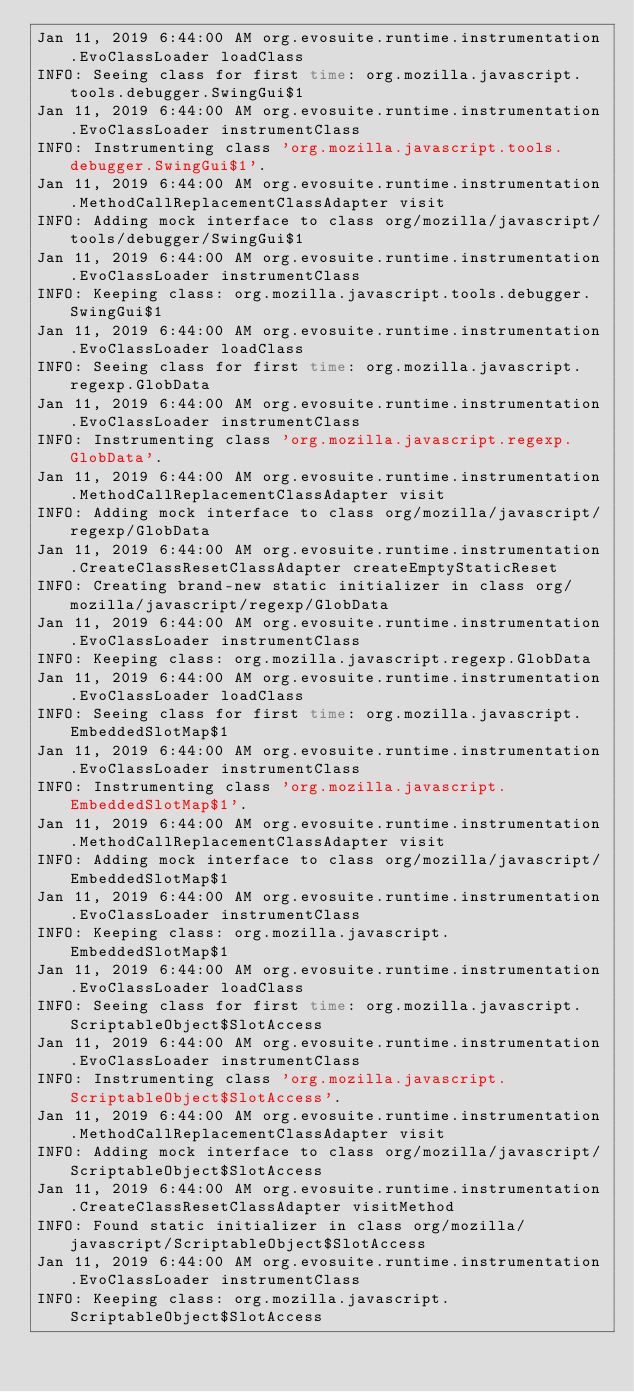<code> <loc_0><loc_0><loc_500><loc_500><_HTML_>Jan 11, 2019 6:44:00 AM org.evosuite.runtime.instrumentation.EvoClassLoader loadClass
INFO: Seeing class for first time: org.mozilla.javascript.tools.debugger.SwingGui$1
Jan 11, 2019 6:44:00 AM org.evosuite.runtime.instrumentation.EvoClassLoader instrumentClass
INFO: Instrumenting class 'org.mozilla.javascript.tools.debugger.SwingGui$1'.
Jan 11, 2019 6:44:00 AM org.evosuite.runtime.instrumentation.MethodCallReplacementClassAdapter visit
INFO: Adding mock interface to class org/mozilla/javascript/tools/debugger/SwingGui$1
Jan 11, 2019 6:44:00 AM org.evosuite.runtime.instrumentation.EvoClassLoader instrumentClass
INFO: Keeping class: org.mozilla.javascript.tools.debugger.SwingGui$1
Jan 11, 2019 6:44:00 AM org.evosuite.runtime.instrumentation.EvoClassLoader loadClass
INFO: Seeing class for first time: org.mozilla.javascript.regexp.GlobData
Jan 11, 2019 6:44:00 AM org.evosuite.runtime.instrumentation.EvoClassLoader instrumentClass
INFO: Instrumenting class 'org.mozilla.javascript.regexp.GlobData'.
Jan 11, 2019 6:44:00 AM org.evosuite.runtime.instrumentation.MethodCallReplacementClassAdapter visit
INFO: Adding mock interface to class org/mozilla/javascript/regexp/GlobData
Jan 11, 2019 6:44:00 AM org.evosuite.runtime.instrumentation.CreateClassResetClassAdapter createEmptyStaticReset
INFO: Creating brand-new static initializer in class org/mozilla/javascript/regexp/GlobData
Jan 11, 2019 6:44:00 AM org.evosuite.runtime.instrumentation.EvoClassLoader instrumentClass
INFO: Keeping class: org.mozilla.javascript.regexp.GlobData
Jan 11, 2019 6:44:00 AM org.evosuite.runtime.instrumentation.EvoClassLoader loadClass
INFO: Seeing class for first time: org.mozilla.javascript.EmbeddedSlotMap$1
Jan 11, 2019 6:44:00 AM org.evosuite.runtime.instrumentation.EvoClassLoader instrumentClass
INFO: Instrumenting class 'org.mozilla.javascript.EmbeddedSlotMap$1'.
Jan 11, 2019 6:44:00 AM org.evosuite.runtime.instrumentation.MethodCallReplacementClassAdapter visit
INFO: Adding mock interface to class org/mozilla/javascript/EmbeddedSlotMap$1
Jan 11, 2019 6:44:00 AM org.evosuite.runtime.instrumentation.EvoClassLoader instrumentClass
INFO: Keeping class: org.mozilla.javascript.EmbeddedSlotMap$1
Jan 11, 2019 6:44:00 AM org.evosuite.runtime.instrumentation.EvoClassLoader loadClass
INFO: Seeing class for first time: org.mozilla.javascript.ScriptableObject$SlotAccess
Jan 11, 2019 6:44:00 AM org.evosuite.runtime.instrumentation.EvoClassLoader instrumentClass
INFO: Instrumenting class 'org.mozilla.javascript.ScriptableObject$SlotAccess'.
Jan 11, 2019 6:44:00 AM org.evosuite.runtime.instrumentation.MethodCallReplacementClassAdapter visit
INFO: Adding mock interface to class org/mozilla/javascript/ScriptableObject$SlotAccess
Jan 11, 2019 6:44:00 AM org.evosuite.runtime.instrumentation.CreateClassResetClassAdapter visitMethod
INFO: Found static initializer in class org/mozilla/javascript/ScriptableObject$SlotAccess
Jan 11, 2019 6:44:00 AM org.evosuite.runtime.instrumentation.EvoClassLoader instrumentClass
INFO: Keeping class: org.mozilla.javascript.ScriptableObject$SlotAccess</code> 